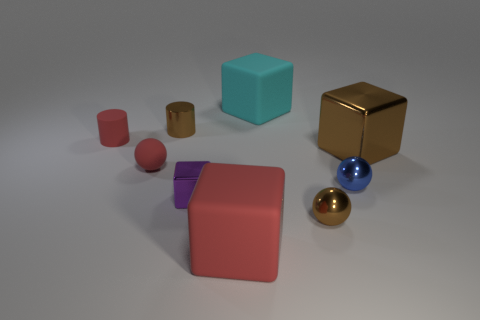Subtract all brown metal blocks. How many blocks are left? 3 Add 1 red cylinders. How many objects exist? 10 Subtract all purple blocks. How many blocks are left? 3 Subtract 3 cubes. How many cubes are left? 1 Add 9 tiny purple blocks. How many tiny purple blocks exist? 10 Subtract 0 gray spheres. How many objects are left? 9 Subtract all spheres. How many objects are left? 6 Subtract all purple spheres. Subtract all yellow cylinders. How many spheres are left? 3 Subtract all red balls. How many cyan cubes are left? 1 Subtract all small blue objects. Subtract all red cylinders. How many objects are left? 7 